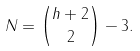<formula> <loc_0><loc_0><loc_500><loc_500>N = { h + 2 \choose 2 } - 3 .</formula> 